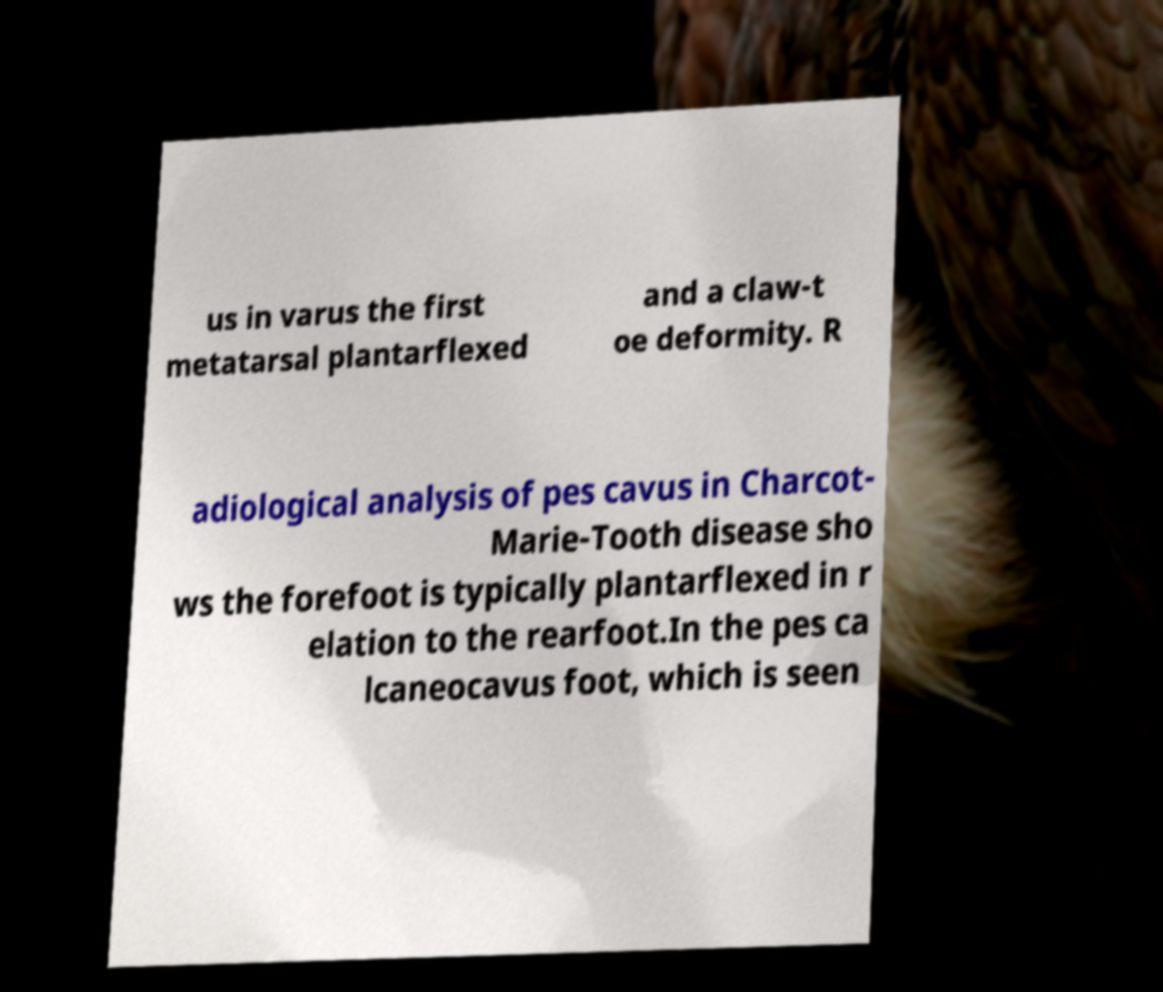For documentation purposes, I need the text within this image transcribed. Could you provide that? us in varus the first metatarsal plantarflexed and a claw-t oe deformity. R adiological analysis of pes cavus in Charcot- Marie-Tooth disease sho ws the forefoot is typically plantarflexed in r elation to the rearfoot.In the pes ca lcaneocavus foot, which is seen 